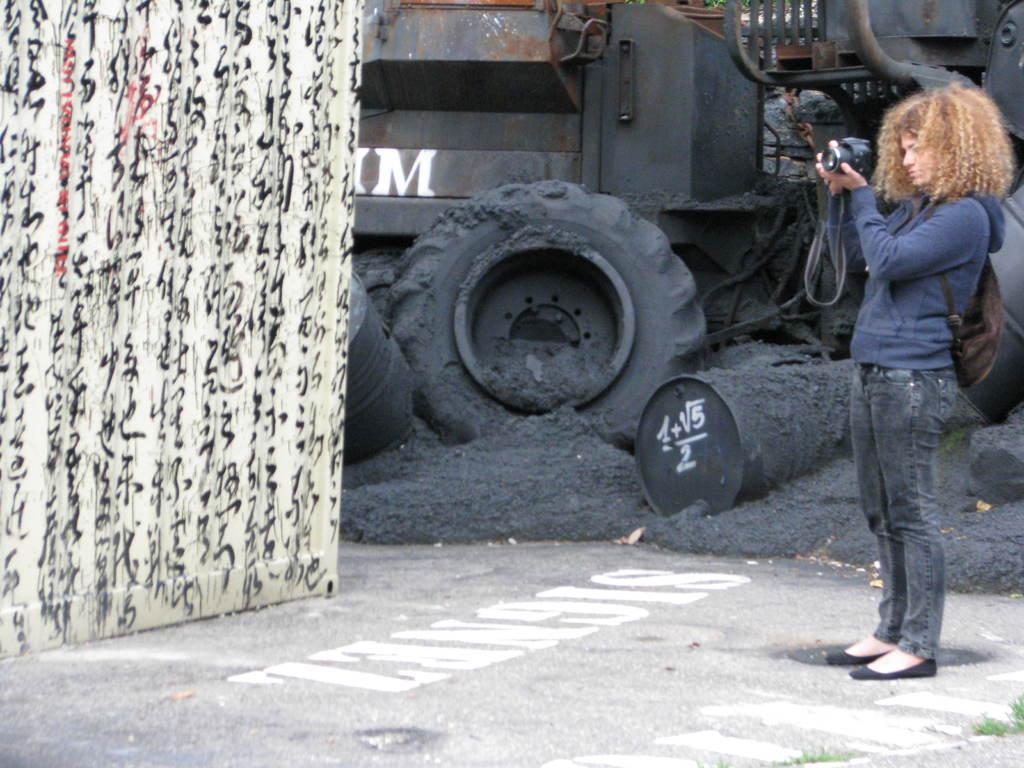Please provide a concise description of this image. In the image we can see a woman standing, wearing clothes and she is holding a camera in her hand. She is carrying a bag on her back. Here we can see the road, grass, wall, metal drums and metal object.  